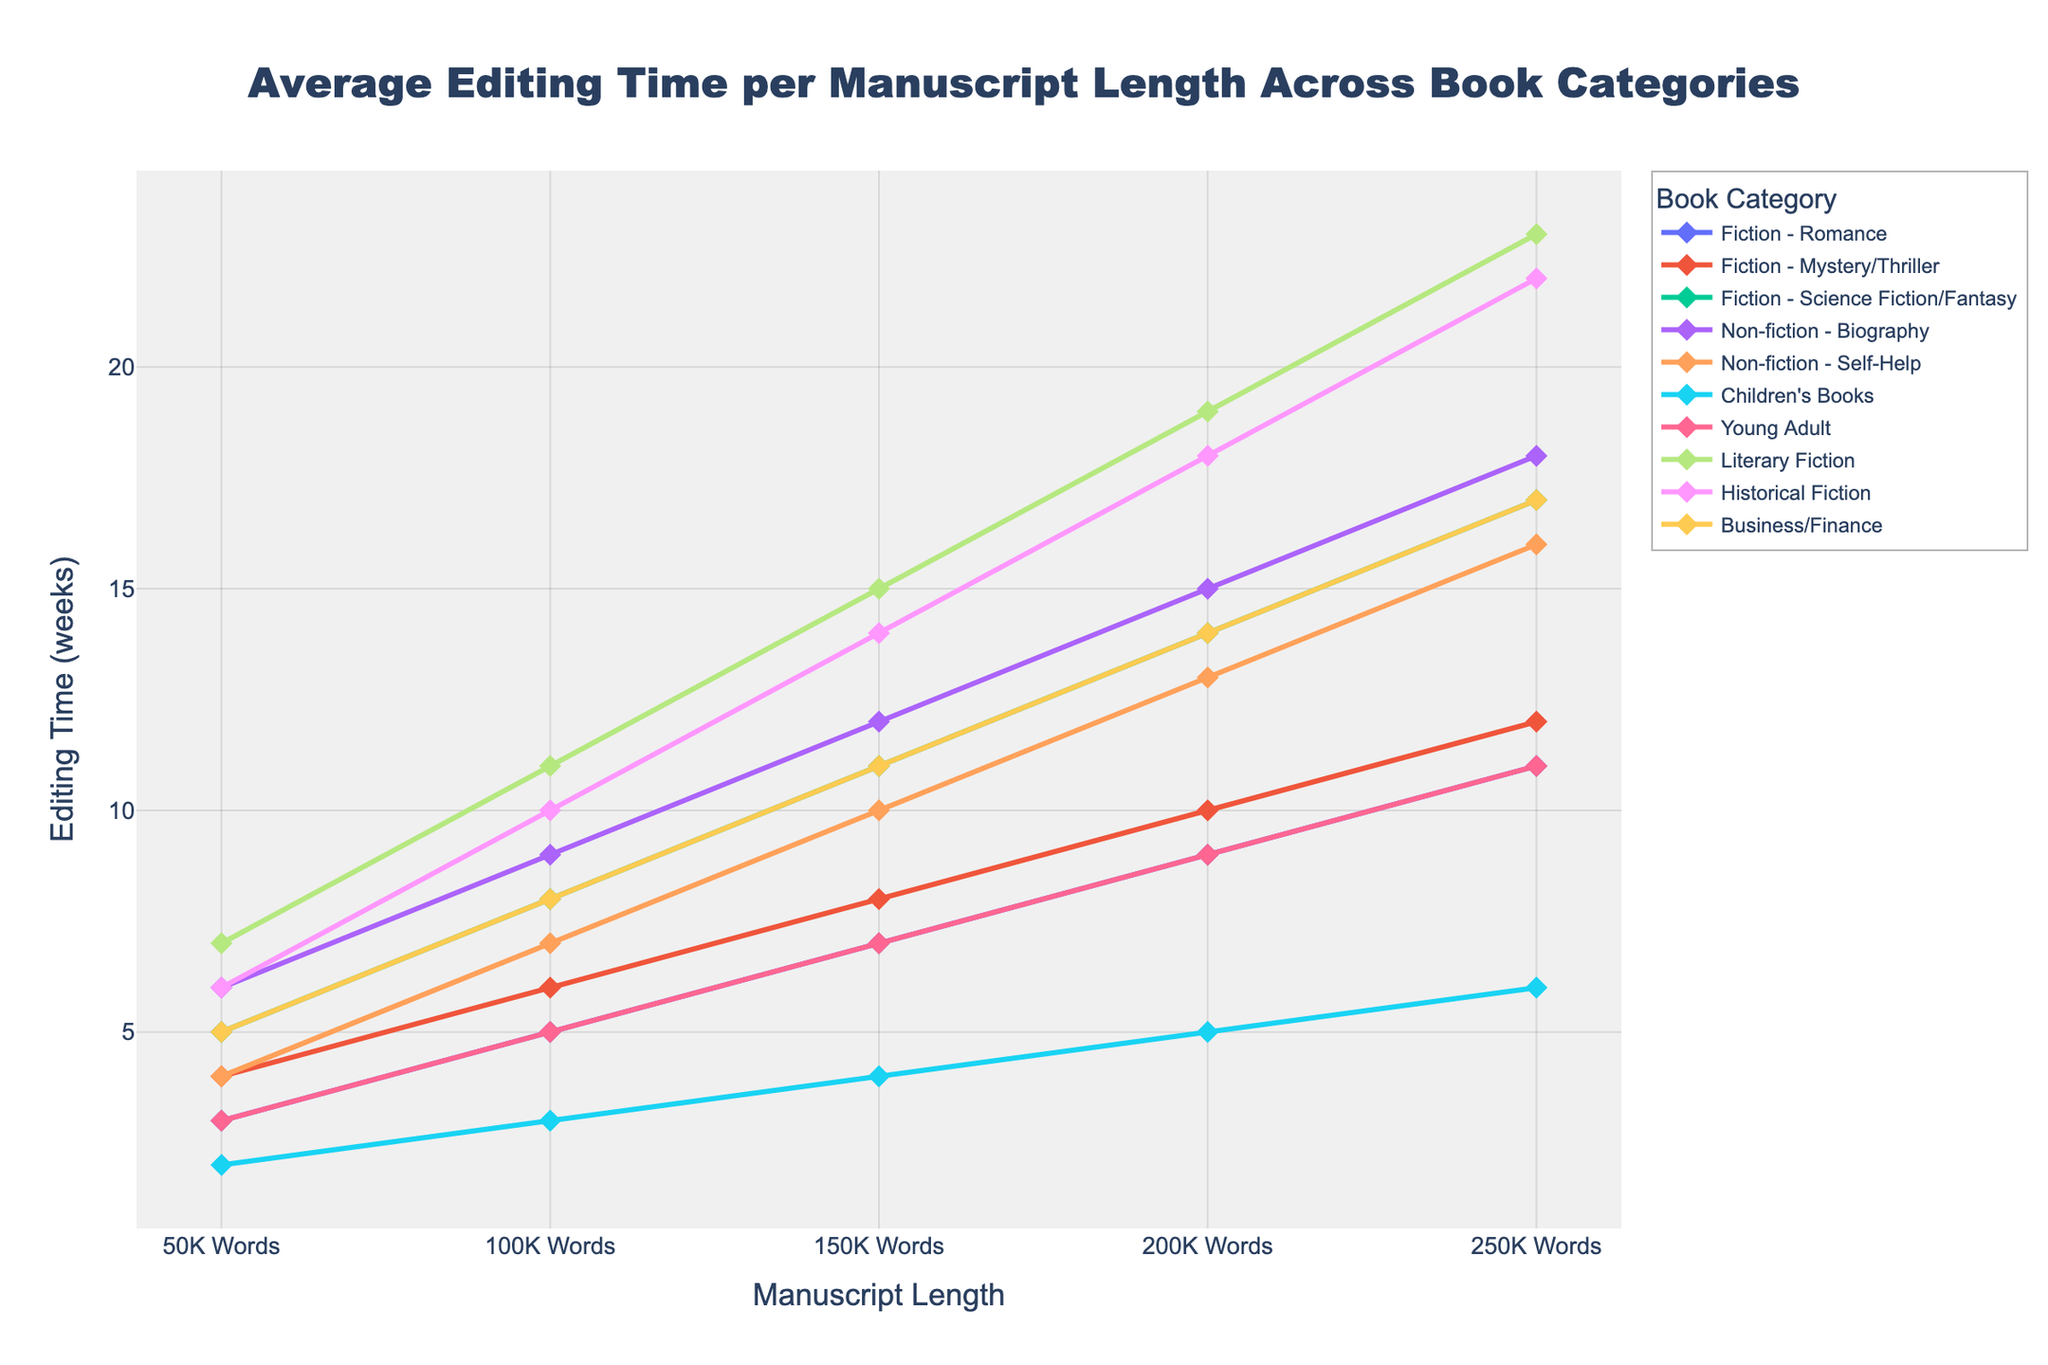Which book category has the highest average editing time for a manuscript length of 100K words? The y-axis represents the editing time in weeks and the line for each book category intersects with the 100K words mark on the x-axis. By comparing the y-values at the 100K words mark, we see that "Literary Fiction" has the highest value at 11 weeks.
Answer: Literary Fiction Which book category sees the biggest increase in editing time when manuscript length increases from 150K words to 200K words? We need to find the difference in editing time between 150K words and 200K words for each category, then compare these differences. For "Literary Fiction," the increase is from 15 to 19 weeks, a difference of 4 weeks. For "Historical Fiction," it's from 14 to 18 weeks, also 4 weeks. However, the largest increase is seen in "Fiction - Science Fiction/Fantasy," from 11 to 14 weeks, a difference of 3 weeks.
Answer: Fiction - Science Fiction/Fantasy What is the combined editing time for the shortest and longest manuscript lengths for the category "Children's Books"? For "Children's Books," the editing time at 50K words is 2 weeks and at 250K words is 6 weeks. Their combined total is 2 + 6 = 8 weeks.
Answer: 8 weeks Which categories have equal editing times for a manuscript length of 50K words? Observing the y-axis values for the 50K words mark and comparing across categories, "Fiction - Romance" and "Young Adult" both have an editing time of 3 weeks.
Answer: Fiction - Romance and Young Adult What is the difference in editing time between "Business/Finance" and "Non-fiction - Biography" at 200K words? At 200K words, the editing time for "Business/Finance" is 14 weeks, and for "Non-fiction - Biography," it's 15 weeks. The difference is 15 - 14 = 1 week.
Answer: 1 week Which category's line intersects with the fewest unique manuscript lengths? By observing the number of unique x-axis points each category line intersects, "Children's Books" intersects with only 5 points: 50K, 100K, 150K, 200K, and 250K words.
Answer: Children's Books Which book category has the steepest upward trend in editing time as manuscript length increases? Observing the slopes of the lines, "Literary Fiction" has the steepest slope as its editing time increases drastically from 7 to 23 weeks across the manuscript lengths.
Answer: Literary Fiction How much more time does it take to edit a 200K-word manuscript compared to a 50K-word manuscript in "Non-fiction - Self-Help"? For "Non-fiction - Self-Help," the editing time at 200K words is 13 weeks and at 50K words is 4 weeks. The difference is 13 - 4 = 9 weeks.
Answer: 9 weeks 